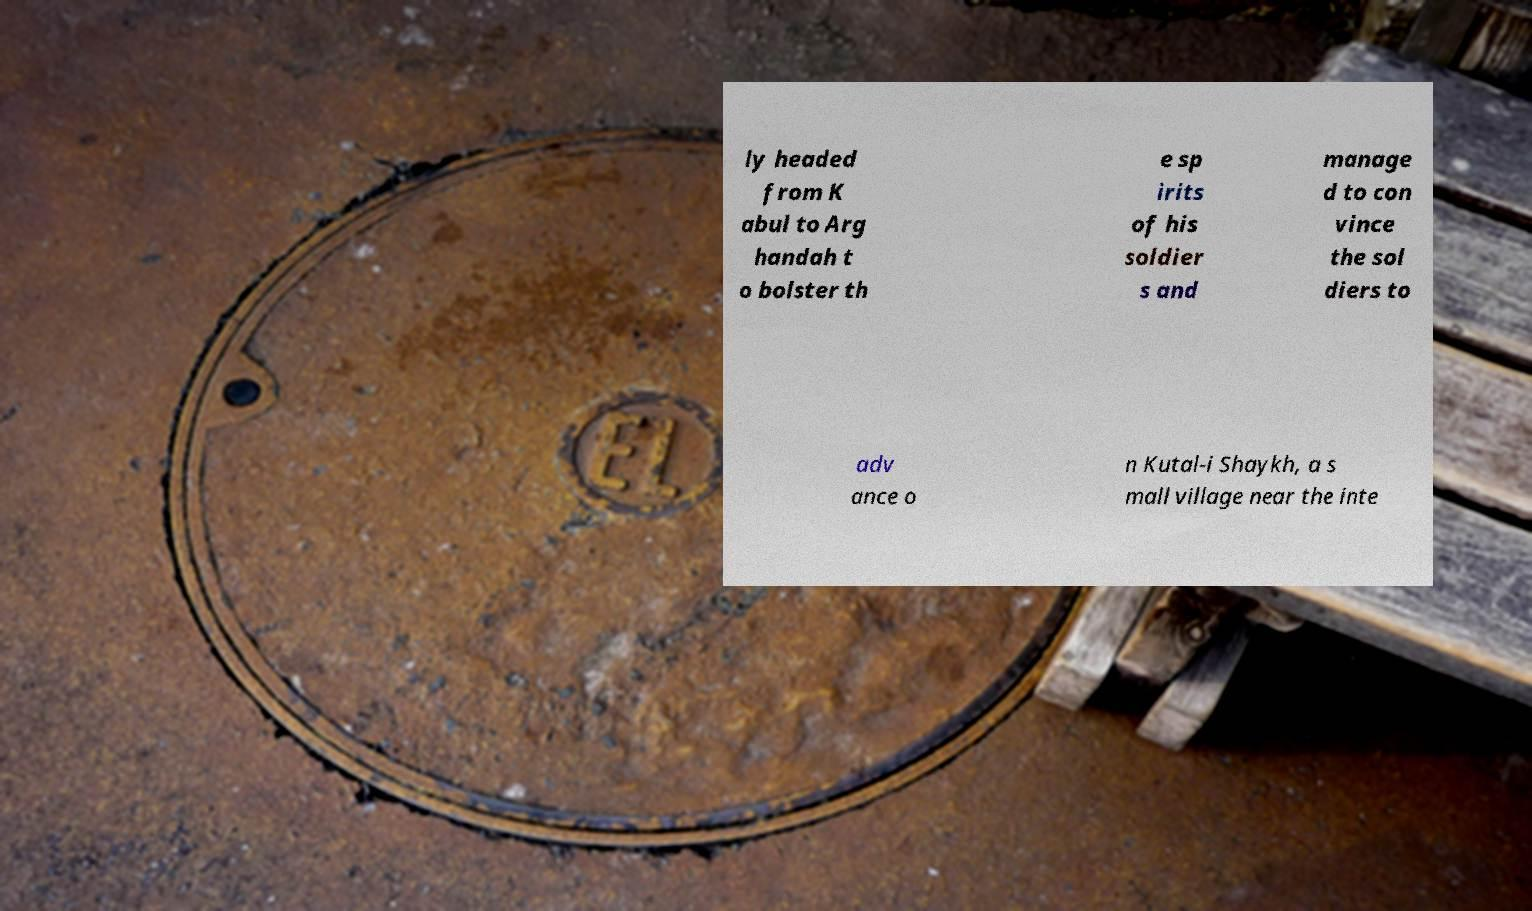For documentation purposes, I need the text within this image transcribed. Could you provide that? ly headed from K abul to Arg handah t o bolster th e sp irits of his soldier s and manage d to con vince the sol diers to adv ance o n Kutal-i Shaykh, a s mall village near the inte 